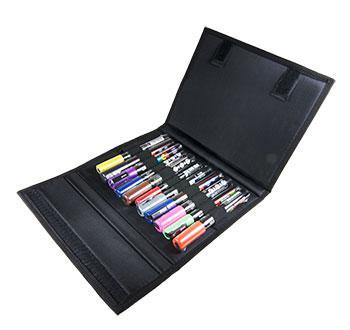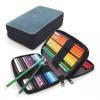The first image is the image on the left, the second image is the image on the right. For the images displayed, is the sentence "One image shows a fold-out pencil case forming a triangle shape and filled with colored-lead pencils." factually correct? Answer yes or no. No. 